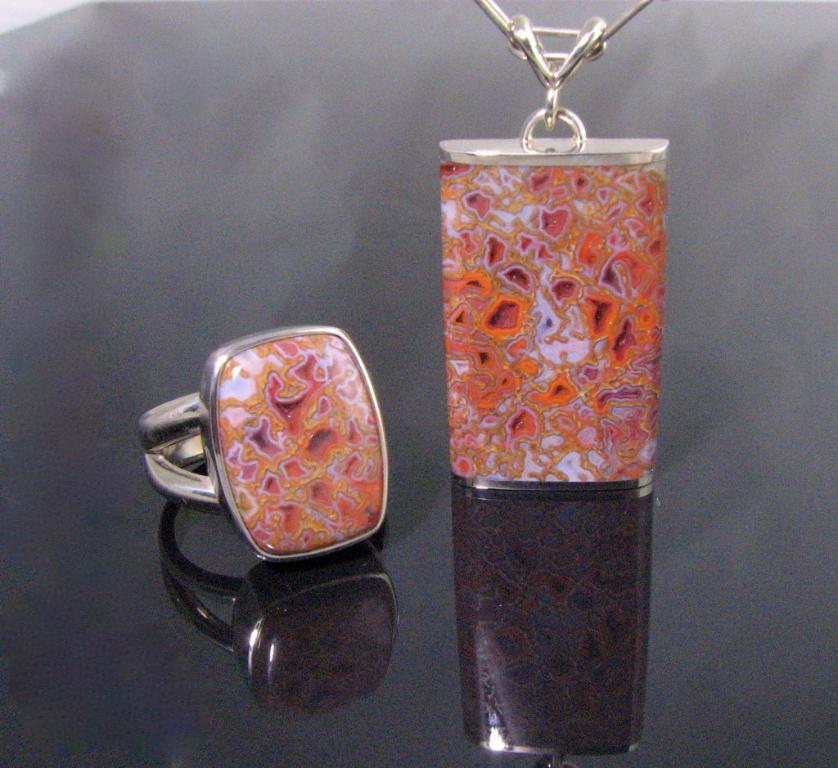What type of jewelry is present in the image? There is a ring and a locket in the image. Where are the ring and locket located in the image? The ring and locket are placed on a platform. What type of mouth can be seen on the zebra in the image? There is no zebra present in the image, so it is not possible to answer that question. 